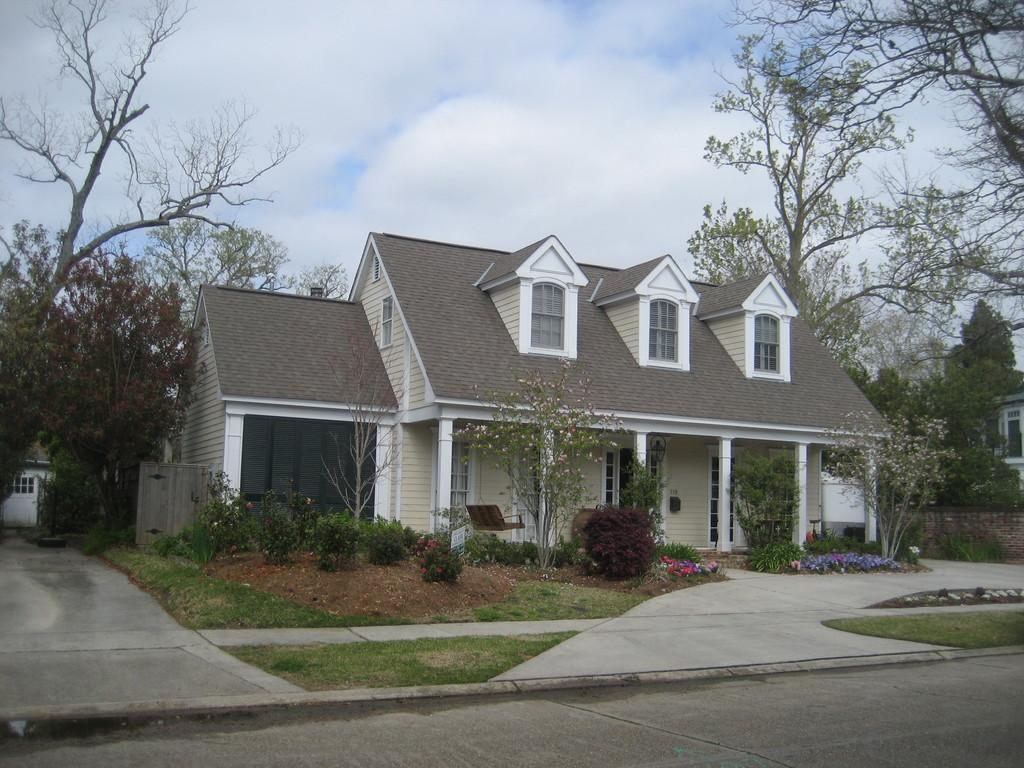What type of structures can be seen in the image? There are houses in the image. What type of vegetation is present in the image? There are trees, plants, and grass visible in the image. What part of the natural environment is visible in the image? The sky is visible in the background of the image. What color is the sock hanging on the clothesline in the image? There is no sock or clothesline present in the image. What type of linen is draped over the furniture in the image? There is no linen or furniture present in the image. 